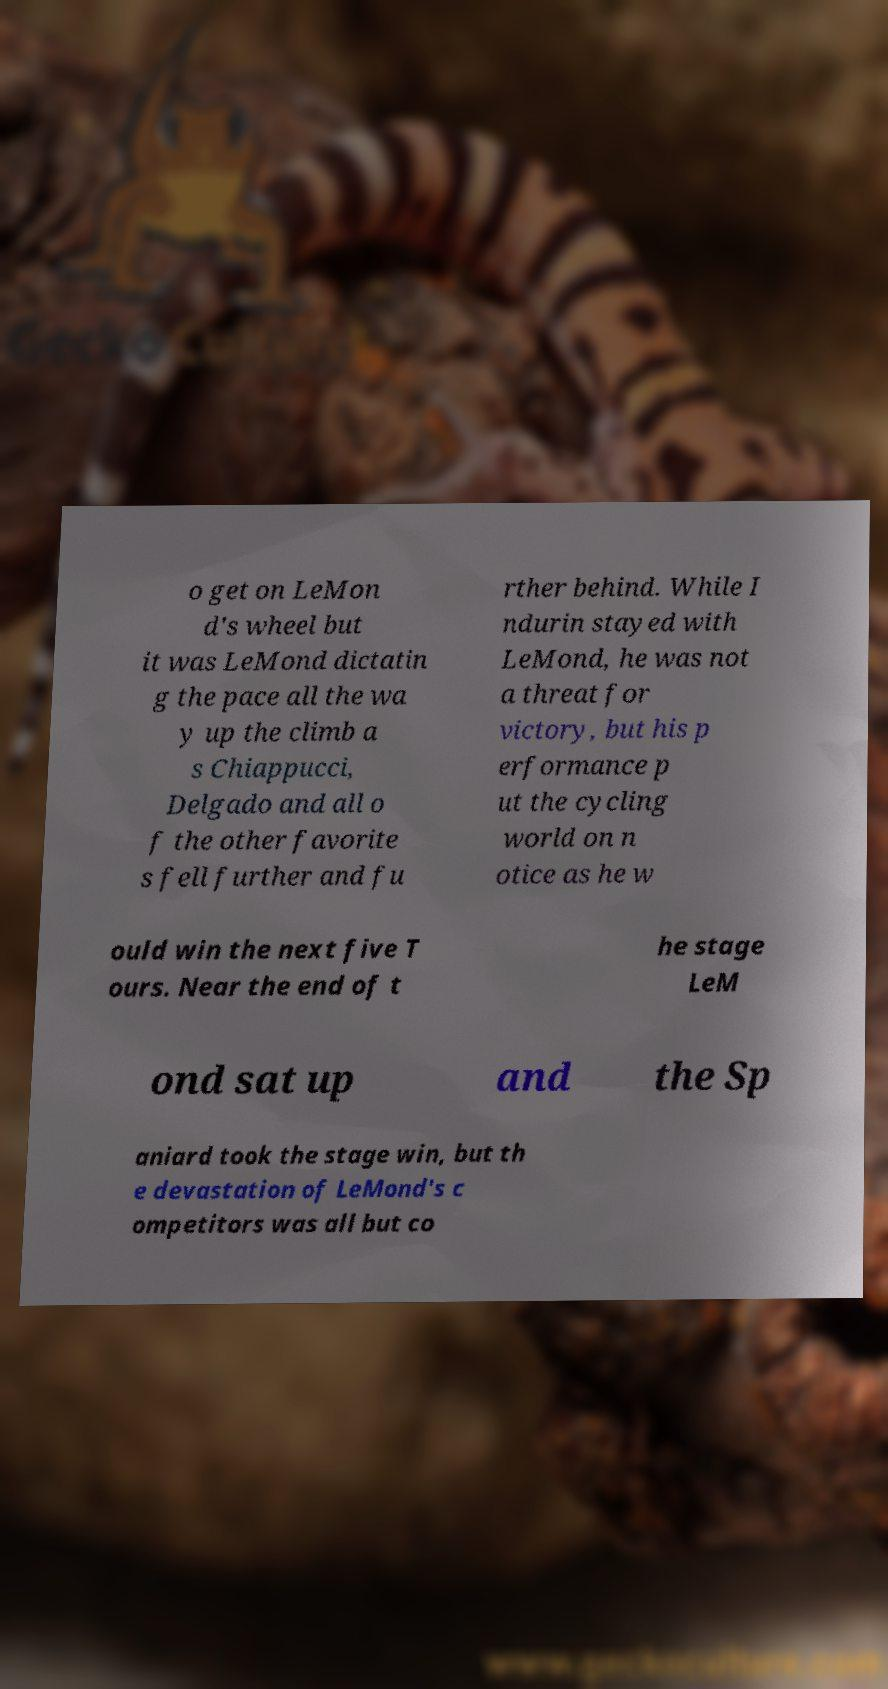Could you extract and type out the text from this image? o get on LeMon d's wheel but it was LeMond dictatin g the pace all the wa y up the climb a s Chiappucci, Delgado and all o f the other favorite s fell further and fu rther behind. While I ndurin stayed with LeMond, he was not a threat for victory, but his p erformance p ut the cycling world on n otice as he w ould win the next five T ours. Near the end of t he stage LeM ond sat up and the Sp aniard took the stage win, but th e devastation of LeMond's c ompetitors was all but co 